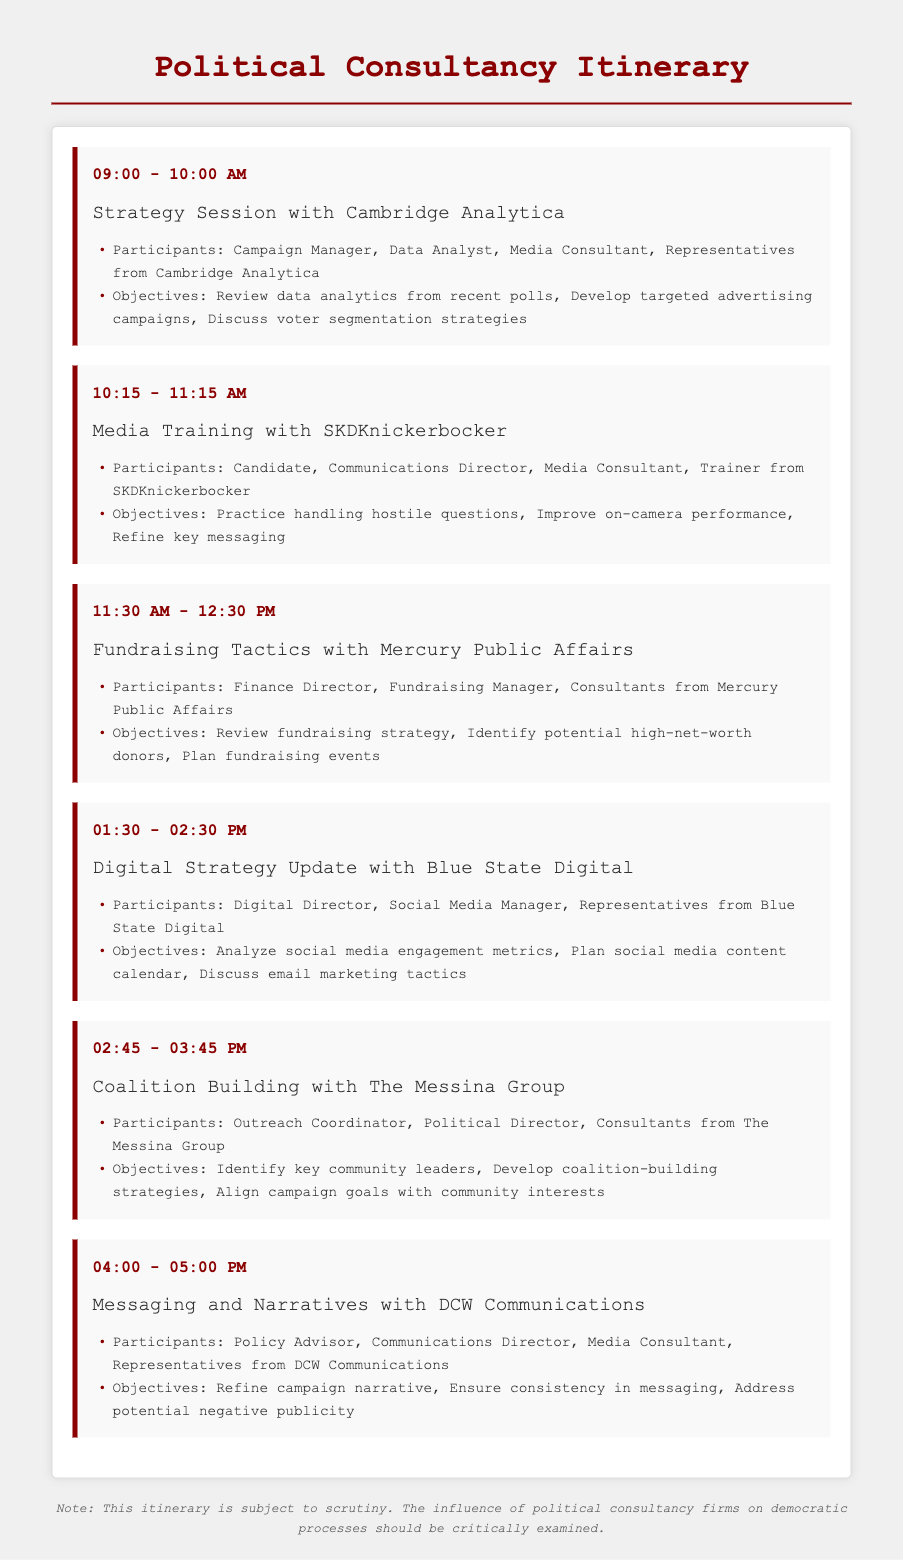What time is the first meeting scheduled? The first meeting is scheduled from 09:00 to 10:00 AM.
Answer: 09:00 - 10:00 AM Who are the participants in the Media Training session? The participants in the Media Training session are the Candidate, Communications Director, Media Consultant, Trainer from SKDKnickerbocker.
Answer: Candidate, Communications Director, Media Consultant, Trainer from SKDKnickerbocker What is the objective of the Digital Strategy Update meeting? The objective of the Digital Strategy Update meeting is to analyze social media engagement metrics, plan social media content calendar, discuss email marketing tactics.
Answer: Analyze social media engagement metrics, plan social media content calendar, discuss email marketing tactics How long is the Coalition Building meeting? The Coalition Building meeting is scheduled for one hour.
Answer: One hour Which consultancy firm is involved in the fundraising tactics meeting? The consultancy firm involved in the fundraising tactics meeting is Mercury Public Affairs.
Answer: Mercury Public Affairs What is the last meeting of the day focused on? The last meeting of the day is focused on messaging and narratives.
Answer: Messaging and narratives How many meetings are scheduled in this itinerary? There are six meetings scheduled in this itinerary.
Answer: Six meetings What is the purpose of the disclaimer at the bottom of the document? The purpose of the disclaimer is to indicate that the itinerary is subject to scrutiny and the influence of political consultancy firms should be critically examined.
Answer: Indicate scrutiny and critical examination 